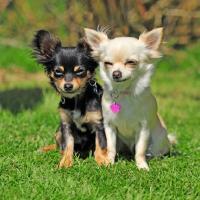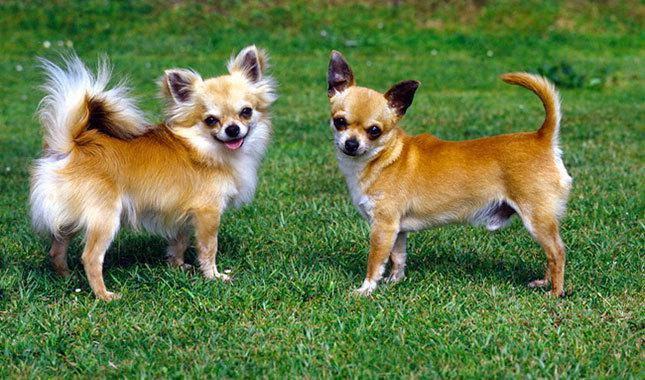The first image is the image on the left, the second image is the image on the right. Examine the images to the left and right. Is the description "There are two dogs standing in the grass in each of the images." accurate? Answer yes or no. Yes. The first image is the image on the left, the second image is the image on the right. Analyze the images presented: Is the assertion "In one image, two furry chihuahuas are posed sitting upright side-by-side, facing the camera." valid? Answer yes or no. Yes. 